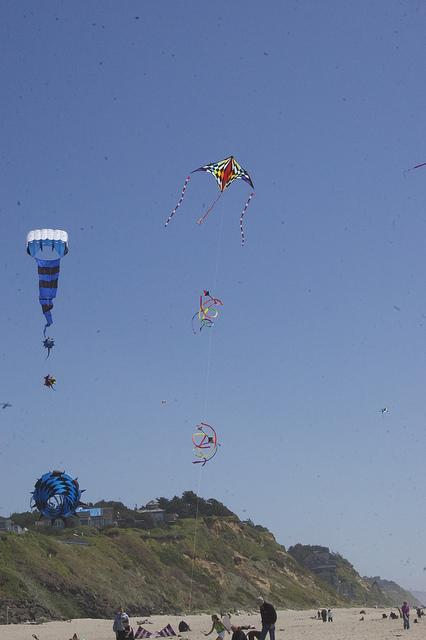What natural disaster are those houses likely safe from? Please explain your reasoning. flooding. The house are very high up on a cliff. 